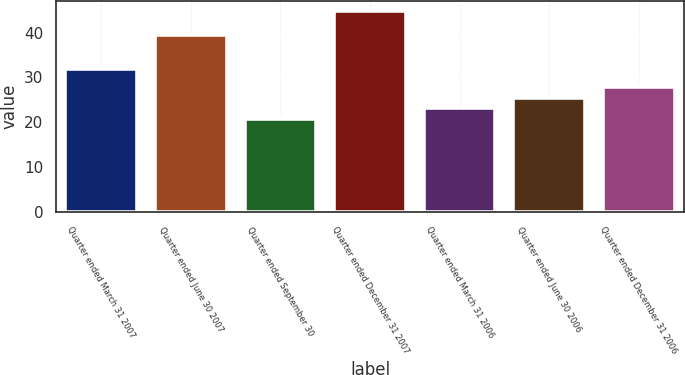Convert chart. <chart><loc_0><loc_0><loc_500><loc_500><bar_chart><fcel>Quarter ended March 31 2007<fcel>Quarter ended June 30 2007<fcel>Quarter ended September 30<fcel>Quarter ended December 31 2007<fcel>Quarter ended March 31 2006<fcel>Quarter ended June 30 2006<fcel>Quarter ended December 31 2006<nl><fcel>32<fcel>39.43<fcel>20.7<fcel>44.9<fcel>23.11<fcel>25.52<fcel>27.93<nl></chart> 